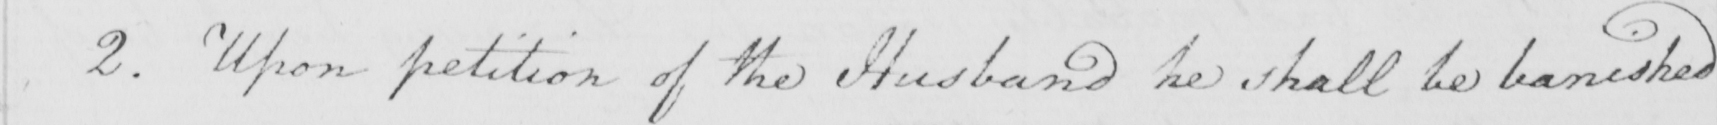What is written in this line of handwriting? 2 . Upon petition of the Husband he shall be banished 